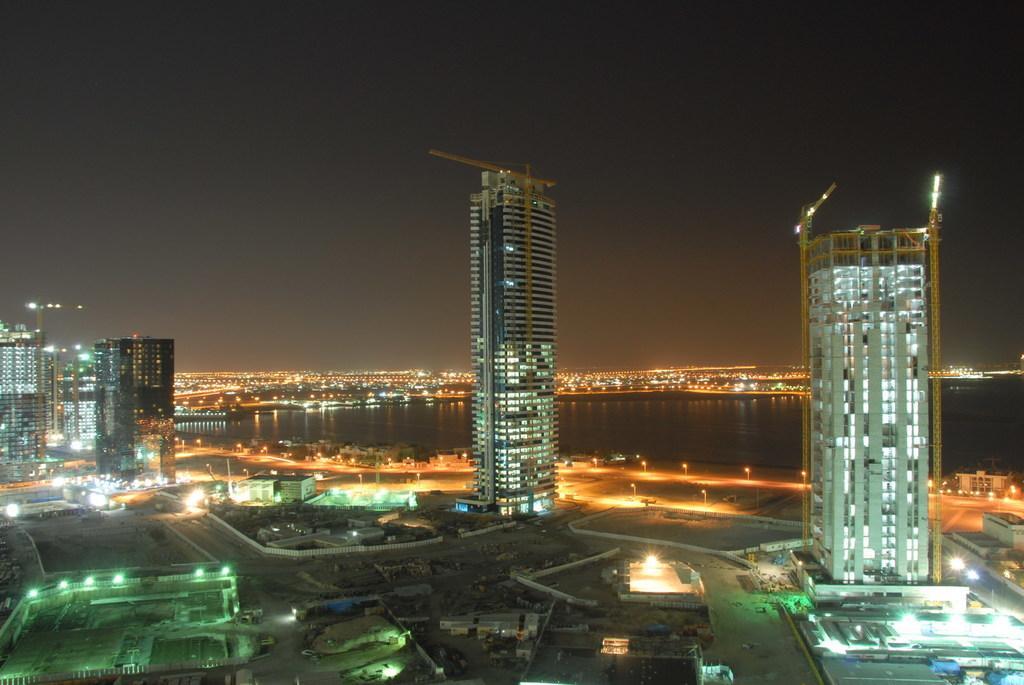Could you give a brief overview of what you see in this image? In this image we can see buildings, lights, also we can see the river and the sky. 